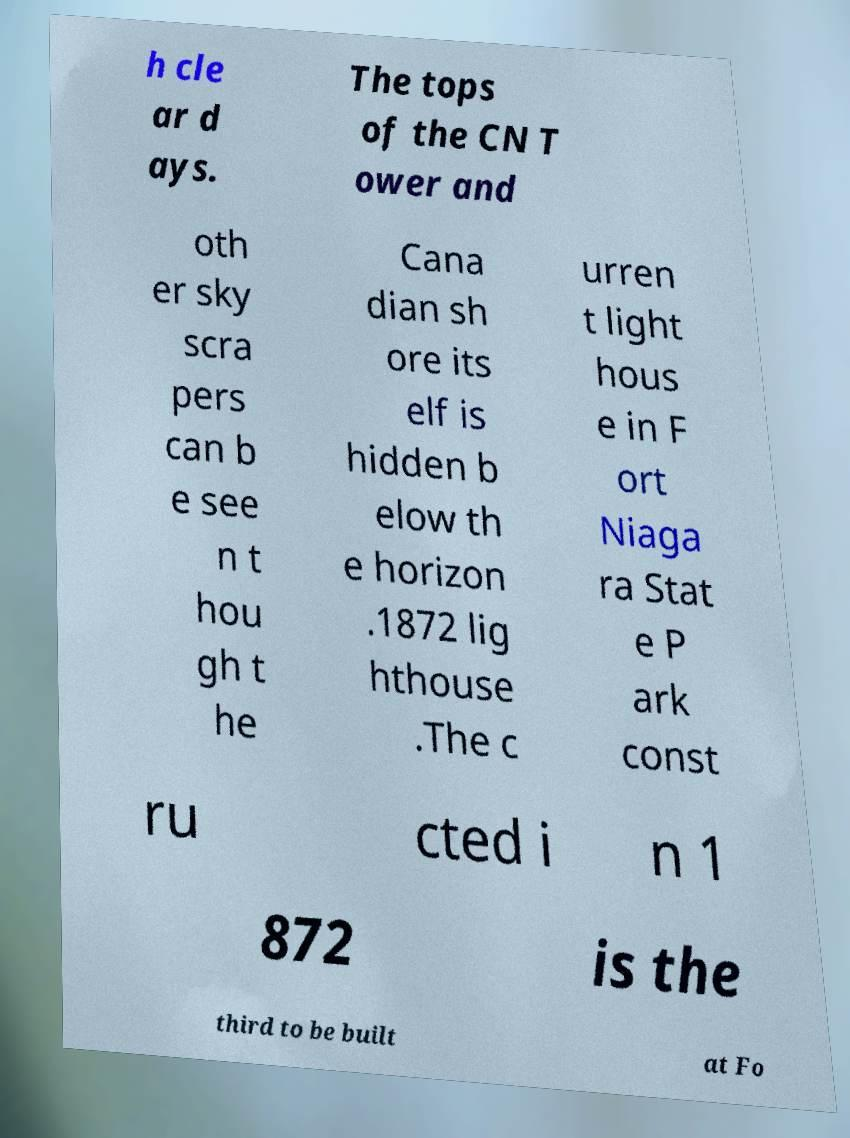Can you read and provide the text displayed in the image?This photo seems to have some interesting text. Can you extract and type it out for me? h cle ar d ays. The tops of the CN T ower and oth er sky scra pers can b e see n t hou gh t he Cana dian sh ore its elf is hidden b elow th e horizon .1872 lig hthouse .The c urren t light hous e in F ort Niaga ra Stat e P ark const ru cted i n 1 872 is the third to be built at Fo 